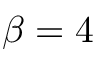Convert formula to latex. <formula><loc_0><loc_0><loc_500><loc_500>\beta = 4</formula> 